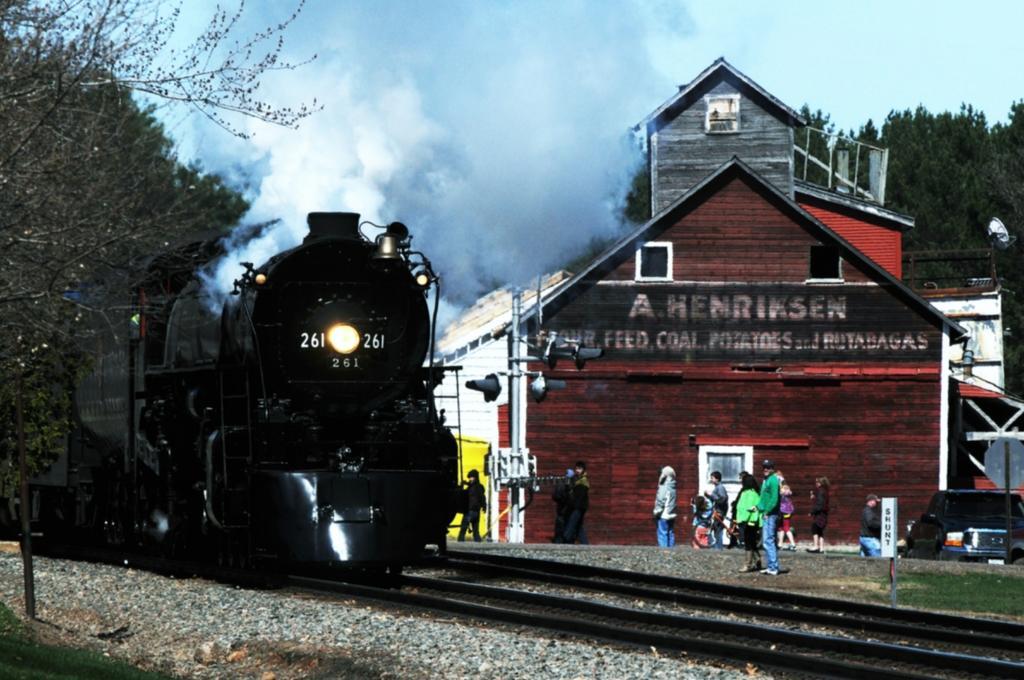Please provide a concise description of this image. In this picture we can see a train on a railway track, trees, stones, building with windows, vehicle and a group of people standing on the ground and in the background we can see the sky with clouds. 